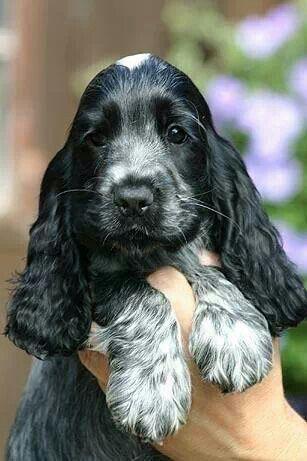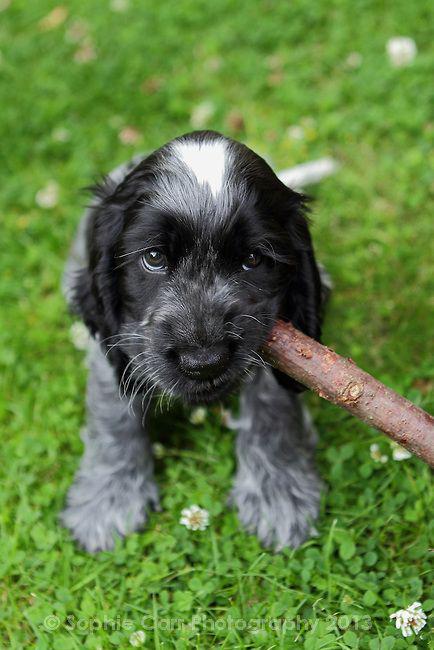The first image is the image on the left, the second image is the image on the right. Assess this claim about the two images: "In one image, a small black and gray dog is being held outdoors with its front paws draped over a hand, while a similar dog in a second image is sitting outdoors.". Correct or not? Answer yes or no. Yes. The first image is the image on the left, the second image is the image on the right. Examine the images to the left and right. Is the description "A floppy eared dog is in contact with a stick-like object in one image." accurate? Answer yes or no. Yes. 